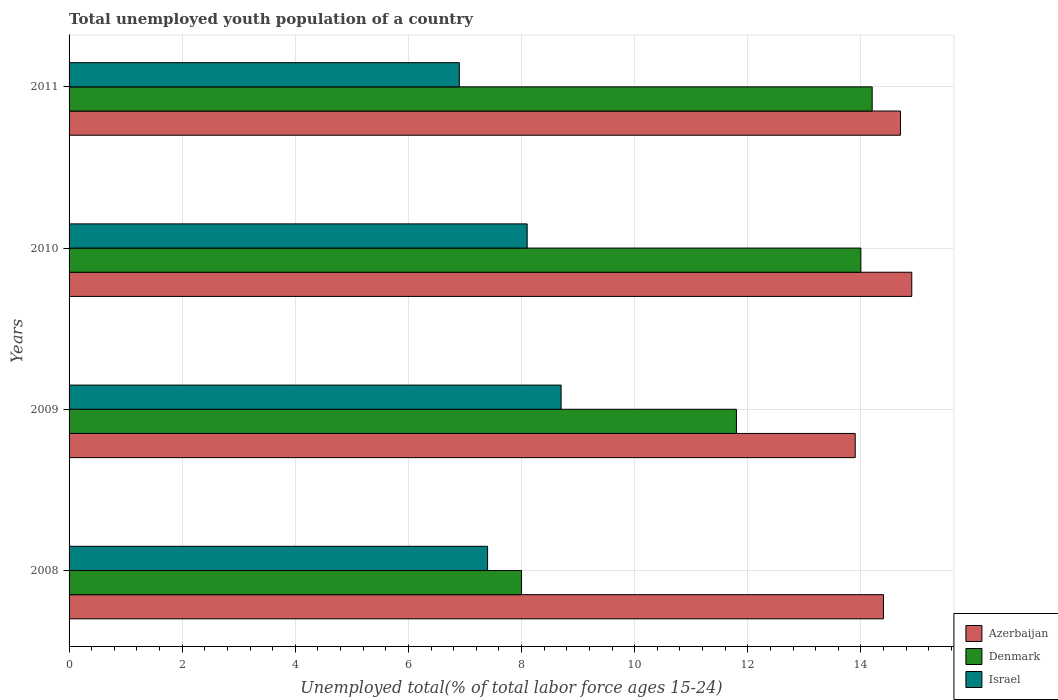How many different coloured bars are there?
Offer a very short reply. 3. How many bars are there on the 3rd tick from the top?
Keep it short and to the point. 3. How many bars are there on the 4th tick from the bottom?
Offer a very short reply. 3. What is the label of the 4th group of bars from the top?
Offer a terse response. 2008. In how many cases, is the number of bars for a given year not equal to the number of legend labels?
Provide a short and direct response. 0. What is the percentage of total unemployed youth population of a country in Azerbaijan in 2009?
Ensure brevity in your answer.  13.9. Across all years, what is the maximum percentage of total unemployed youth population of a country in Denmark?
Provide a succinct answer. 14.2. Across all years, what is the minimum percentage of total unemployed youth population of a country in Azerbaijan?
Make the answer very short. 13.9. In which year was the percentage of total unemployed youth population of a country in Israel maximum?
Your answer should be compact. 2009. What is the total percentage of total unemployed youth population of a country in Azerbaijan in the graph?
Provide a short and direct response. 57.9. What is the difference between the percentage of total unemployed youth population of a country in Israel in 2008 and that in 2010?
Ensure brevity in your answer.  -0.7. What is the difference between the percentage of total unemployed youth population of a country in Azerbaijan in 2010 and the percentage of total unemployed youth population of a country in Israel in 2011?
Provide a succinct answer. 8. In the year 2011, what is the difference between the percentage of total unemployed youth population of a country in Denmark and percentage of total unemployed youth population of a country in Azerbaijan?
Your answer should be very brief. -0.5. What is the ratio of the percentage of total unemployed youth population of a country in Israel in 2009 to that in 2011?
Keep it short and to the point. 1.26. What is the difference between the highest and the second highest percentage of total unemployed youth population of a country in Israel?
Keep it short and to the point. 0.6. What is the difference between the highest and the lowest percentage of total unemployed youth population of a country in Azerbaijan?
Provide a short and direct response. 1. In how many years, is the percentage of total unemployed youth population of a country in Israel greater than the average percentage of total unemployed youth population of a country in Israel taken over all years?
Ensure brevity in your answer.  2. Is the sum of the percentage of total unemployed youth population of a country in Denmark in 2008 and 2011 greater than the maximum percentage of total unemployed youth population of a country in Israel across all years?
Ensure brevity in your answer.  Yes. What does the 1st bar from the bottom in 2010 represents?
Make the answer very short. Azerbaijan. How many bars are there?
Keep it short and to the point. 12. How many years are there in the graph?
Ensure brevity in your answer.  4. Does the graph contain any zero values?
Provide a short and direct response. No. Does the graph contain grids?
Make the answer very short. Yes. Where does the legend appear in the graph?
Keep it short and to the point. Bottom right. What is the title of the graph?
Your answer should be compact. Total unemployed youth population of a country. Does "Portugal" appear as one of the legend labels in the graph?
Keep it short and to the point. No. What is the label or title of the X-axis?
Offer a very short reply. Unemployed total(% of total labor force ages 15-24). What is the Unemployed total(% of total labor force ages 15-24) of Azerbaijan in 2008?
Give a very brief answer. 14.4. What is the Unemployed total(% of total labor force ages 15-24) in Denmark in 2008?
Your answer should be compact. 8. What is the Unemployed total(% of total labor force ages 15-24) in Israel in 2008?
Make the answer very short. 7.4. What is the Unemployed total(% of total labor force ages 15-24) in Azerbaijan in 2009?
Offer a very short reply. 13.9. What is the Unemployed total(% of total labor force ages 15-24) in Denmark in 2009?
Offer a terse response. 11.8. What is the Unemployed total(% of total labor force ages 15-24) in Israel in 2009?
Offer a very short reply. 8.7. What is the Unemployed total(% of total labor force ages 15-24) in Azerbaijan in 2010?
Provide a succinct answer. 14.9. What is the Unemployed total(% of total labor force ages 15-24) in Israel in 2010?
Provide a short and direct response. 8.1. What is the Unemployed total(% of total labor force ages 15-24) of Azerbaijan in 2011?
Give a very brief answer. 14.7. What is the Unemployed total(% of total labor force ages 15-24) of Denmark in 2011?
Offer a very short reply. 14.2. What is the Unemployed total(% of total labor force ages 15-24) of Israel in 2011?
Your answer should be compact. 6.9. Across all years, what is the maximum Unemployed total(% of total labor force ages 15-24) of Azerbaijan?
Ensure brevity in your answer.  14.9. Across all years, what is the maximum Unemployed total(% of total labor force ages 15-24) of Denmark?
Your answer should be compact. 14.2. Across all years, what is the maximum Unemployed total(% of total labor force ages 15-24) in Israel?
Ensure brevity in your answer.  8.7. Across all years, what is the minimum Unemployed total(% of total labor force ages 15-24) in Azerbaijan?
Make the answer very short. 13.9. Across all years, what is the minimum Unemployed total(% of total labor force ages 15-24) of Denmark?
Give a very brief answer. 8. Across all years, what is the minimum Unemployed total(% of total labor force ages 15-24) in Israel?
Give a very brief answer. 6.9. What is the total Unemployed total(% of total labor force ages 15-24) in Azerbaijan in the graph?
Ensure brevity in your answer.  57.9. What is the total Unemployed total(% of total labor force ages 15-24) in Israel in the graph?
Provide a short and direct response. 31.1. What is the difference between the Unemployed total(% of total labor force ages 15-24) in Azerbaijan in 2008 and that in 2009?
Give a very brief answer. 0.5. What is the difference between the Unemployed total(% of total labor force ages 15-24) in Israel in 2008 and that in 2009?
Offer a terse response. -1.3. What is the difference between the Unemployed total(% of total labor force ages 15-24) of Denmark in 2008 and that in 2010?
Ensure brevity in your answer.  -6. What is the difference between the Unemployed total(% of total labor force ages 15-24) in Azerbaijan in 2008 and that in 2011?
Offer a very short reply. -0.3. What is the difference between the Unemployed total(% of total labor force ages 15-24) of Denmark in 2008 and that in 2011?
Keep it short and to the point. -6.2. What is the difference between the Unemployed total(% of total labor force ages 15-24) of Israel in 2008 and that in 2011?
Your answer should be compact. 0.5. What is the difference between the Unemployed total(% of total labor force ages 15-24) in Azerbaijan in 2009 and that in 2011?
Keep it short and to the point. -0.8. What is the difference between the Unemployed total(% of total labor force ages 15-24) in Israel in 2010 and that in 2011?
Your response must be concise. 1.2. What is the difference between the Unemployed total(% of total labor force ages 15-24) of Denmark in 2008 and the Unemployed total(% of total labor force ages 15-24) of Israel in 2009?
Give a very brief answer. -0.7. What is the difference between the Unemployed total(% of total labor force ages 15-24) of Denmark in 2008 and the Unemployed total(% of total labor force ages 15-24) of Israel in 2010?
Provide a succinct answer. -0.1. What is the difference between the Unemployed total(% of total labor force ages 15-24) in Azerbaijan in 2008 and the Unemployed total(% of total labor force ages 15-24) in Denmark in 2011?
Your answer should be compact. 0.2. What is the difference between the Unemployed total(% of total labor force ages 15-24) in Azerbaijan in 2008 and the Unemployed total(% of total labor force ages 15-24) in Israel in 2011?
Your response must be concise. 7.5. What is the difference between the Unemployed total(% of total labor force ages 15-24) of Denmark in 2008 and the Unemployed total(% of total labor force ages 15-24) of Israel in 2011?
Provide a short and direct response. 1.1. What is the difference between the Unemployed total(% of total labor force ages 15-24) of Azerbaijan in 2009 and the Unemployed total(% of total labor force ages 15-24) of Denmark in 2010?
Offer a terse response. -0.1. What is the difference between the Unemployed total(% of total labor force ages 15-24) in Azerbaijan in 2009 and the Unemployed total(% of total labor force ages 15-24) in Israel in 2010?
Offer a terse response. 5.8. What is the difference between the Unemployed total(% of total labor force ages 15-24) of Azerbaijan in 2009 and the Unemployed total(% of total labor force ages 15-24) of Denmark in 2011?
Keep it short and to the point. -0.3. What is the difference between the Unemployed total(% of total labor force ages 15-24) in Azerbaijan in 2010 and the Unemployed total(% of total labor force ages 15-24) in Denmark in 2011?
Your response must be concise. 0.7. What is the average Unemployed total(% of total labor force ages 15-24) of Azerbaijan per year?
Make the answer very short. 14.47. What is the average Unemployed total(% of total labor force ages 15-24) of Denmark per year?
Offer a very short reply. 12. What is the average Unemployed total(% of total labor force ages 15-24) in Israel per year?
Offer a very short reply. 7.78. In the year 2008, what is the difference between the Unemployed total(% of total labor force ages 15-24) of Azerbaijan and Unemployed total(% of total labor force ages 15-24) of Denmark?
Your answer should be compact. 6.4. In the year 2008, what is the difference between the Unemployed total(% of total labor force ages 15-24) of Azerbaijan and Unemployed total(% of total labor force ages 15-24) of Israel?
Offer a very short reply. 7. In the year 2009, what is the difference between the Unemployed total(% of total labor force ages 15-24) of Azerbaijan and Unemployed total(% of total labor force ages 15-24) of Israel?
Your response must be concise. 5.2. In the year 2009, what is the difference between the Unemployed total(% of total labor force ages 15-24) in Denmark and Unemployed total(% of total labor force ages 15-24) in Israel?
Your answer should be very brief. 3.1. In the year 2010, what is the difference between the Unemployed total(% of total labor force ages 15-24) in Azerbaijan and Unemployed total(% of total labor force ages 15-24) in Israel?
Offer a very short reply. 6.8. In the year 2010, what is the difference between the Unemployed total(% of total labor force ages 15-24) of Denmark and Unemployed total(% of total labor force ages 15-24) of Israel?
Ensure brevity in your answer.  5.9. In the year 2011, what is the difference between the Unemployed total(% of total labor force ages 15-24) of Azerbaijan and Unemployed total(% of total labor force ages 15-24) of Denmark?
Your response must be concise. 0.5. In the year 2011, what is the difference between the Unemployed total(% of total labor force ages 15-24) of Azerbaijan and Unemployed total(% of total labor force ages 15-24) of Israel?
Keep it short and to the point. 7.8. What is the ratio of the Unemployed total(% of total labor force ages 15-24) in Azerbaijan in 2008 to that in 2009?
Offer a very short reply. 1.04. What is the ratio of the Unemployed total(% of total labor force ages 15-24) of Denmark in 2008 to that in 2009?
Offer a very short reply. 0.68. What is the ratio of the Unemployed total(% of total labor force ages 15-24) in Israel in 2008 to that in 2009?
Provide a short and direct response. 0.85. What is the ratio of the Unemployed total(% of total labor force ages 15-24) of Azerbaijan in 2008 to that in 2010?
Provide a succinct answer. 0.97. What is the ratio of the Unemployed total(% of total labor force ages 15-24) of Israel in 2008 to that in 2010?
Your response must be concise. 0.91. What is the ratio of the Unemployed total(% of total labor force ages 15-24) in Azerbaijan in 2008 to that in 2011?
Offer a terse response. 0.98. What is the ratio of the Unemployed total(% of total labor force ages 15-24) of Denmark in 2008 to that in 2011?
Keep it short and to the point. 0.56. What is the ratio of the Unemployed total(% of total labor force ages 15-24) of Israel in 2008 to that in 2011?
Provide a succinct answer. 1.07. What is the ratio of the Unemployed total(% of total labor force ages 15-24) in Azerbaijan in 2009 to that in 2010?
Offer a very short reply. 0.93. What is the ratio of the Unemployed total(% of total labor force ages 15-24) of Denmark in 2009 to that in 2010?
Offer a terse response. 0.84. What is the ratio of the Unemployed total(% of total labor force ages 15-24) in Israel in 2009 to that in 2010?
Keep it short and to the point. 1.07. What is the ratio of the Unemployed total(% of total labor force ages 15-24) of Azerbaijan in 2009 to that in 2011?
Provide a short and direct response. 0.95. What is the ratio of the Unemployed total(% of total labor force ages 15-24) in Denmark in 2009 to that in 2011?
Give a very brief answer. 0.83. What is the ratio of the Unemployed total(% of total labor force ages 15-24) in Israel in 2009 to that in 2011?
Your response must be concise. 1.26. What is the ratio of the Unemployed total(% of total labor force ages 15-24) in Azerbaijan in 2010 to that in 2011?
Your response must be concise. 1.01. What is the ratio of the Unemployed total(% of total labor force ages 15-24) in Denmark in 2010 to that in 2011?
Keep it short and to the point. 0.99. What is the ratio of the Unemployed total(% of total labor force ages 15-24) in Israel in 2010 to that in 2011?
Offer a terse response. 1.17. What is the difference between the highest and the lowest Unemployed total(% of total labor force ages 15-24) in Azerbaijan?
Your response must be concise. 1. What is the difference between the highest and the lowest Unemployed total(% of total labor force ages 15-24) in Israel?
Keep it short and to the point. 1.8. 